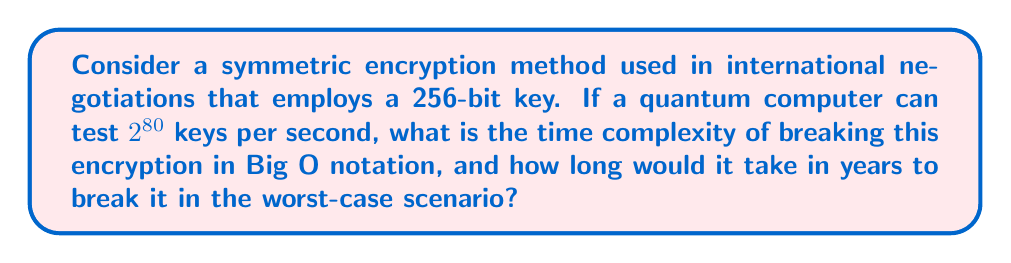Help me with this question. Let's approach this step-by-step:

1) The encryption method uses a 256-bit key. This means there are $2^{256}$ possible keys.

2) In the worst-case scenario, we might need to try all possible keys before finding the correct one. This is known as a brute-force attack.

3) The time complexity of a brute-force attack is directly proportional to the number of possible keys. Therefore, the time complexity in Big O notation is $O(2^{256})$.

4) To calculate the actual time it would take:
   
   - The quantum computer can test $2^{80}$ keys per second
   - Total number of keys to test: $2^{256}$
   - Time required = $\frac{2^{256}}{2^{80}} = 2^{176}$ seconds

5) To convert this to years:
   
   $$\text{Years} = \frac{2^{176}}{60 \times 60 \times 24 \times 365.25}$$

6) Simplifying:
   
   $$\text{Years} \approx 2^{176} \times 3.17 \times 10^{-8} \approx 2^{174}$$

This is an astronomically large number, far exceeding the age of the universe.
Answer: $O(2^{256})$; $2^{174}$ years 